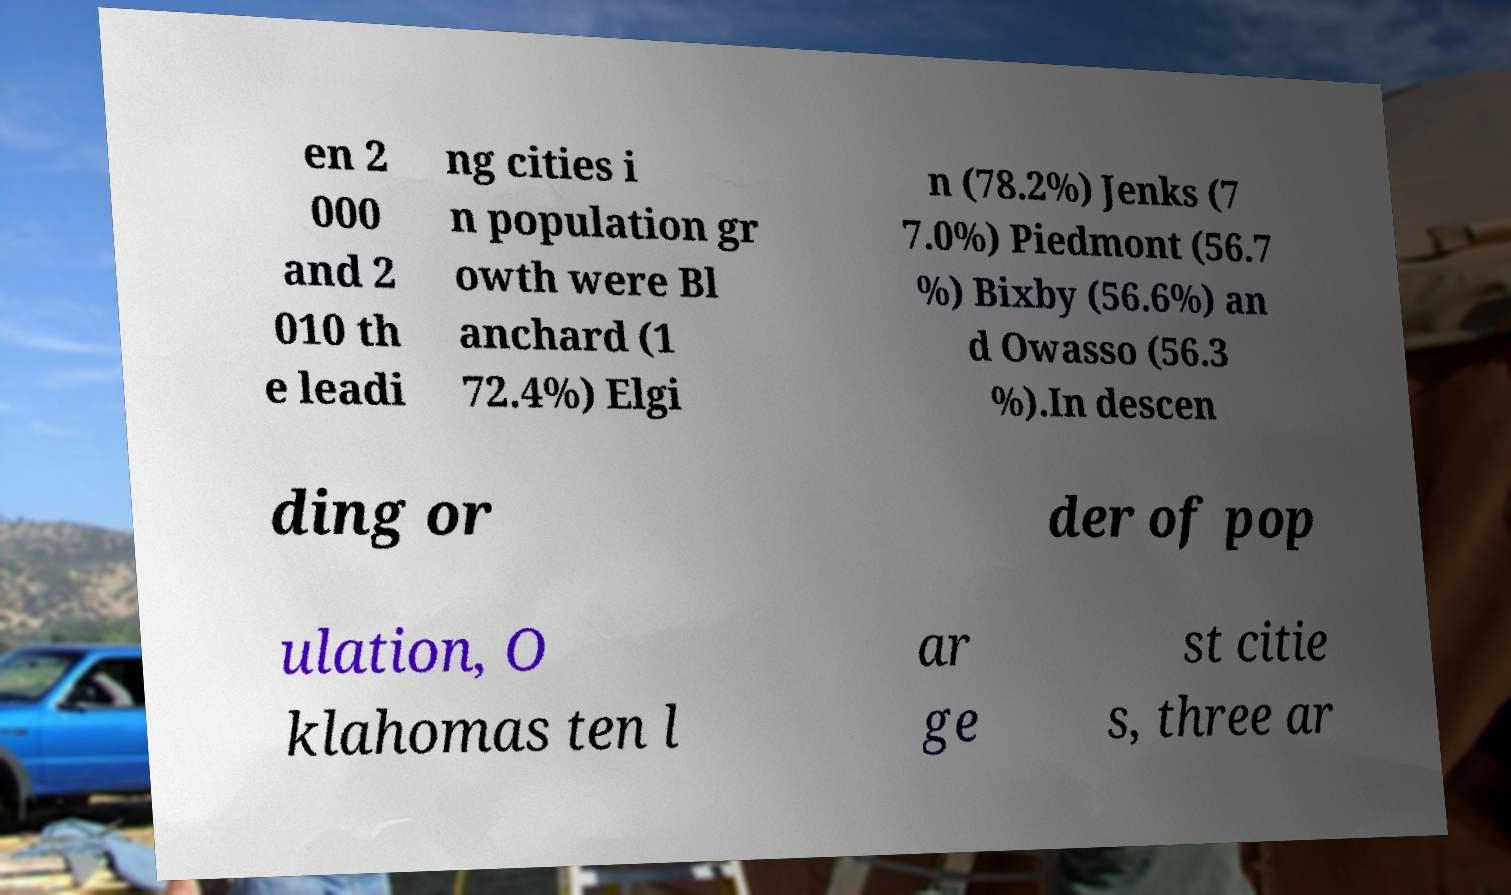What messages or text are displayed in this image? I need them in a readable, typed format. en 2 000 and 2 010 th e leadi ng cities i n population gr owth were Bl anchard (1 72.4%) Elgi n (78.2%) Jenks (7 7.0%) Piedmont (56.7 %) Bixby (56.6%) an d Owasso (56.3 %).In descen ding or der of pop ulation, O klahomas ten l ar ge st citie s, three ar 